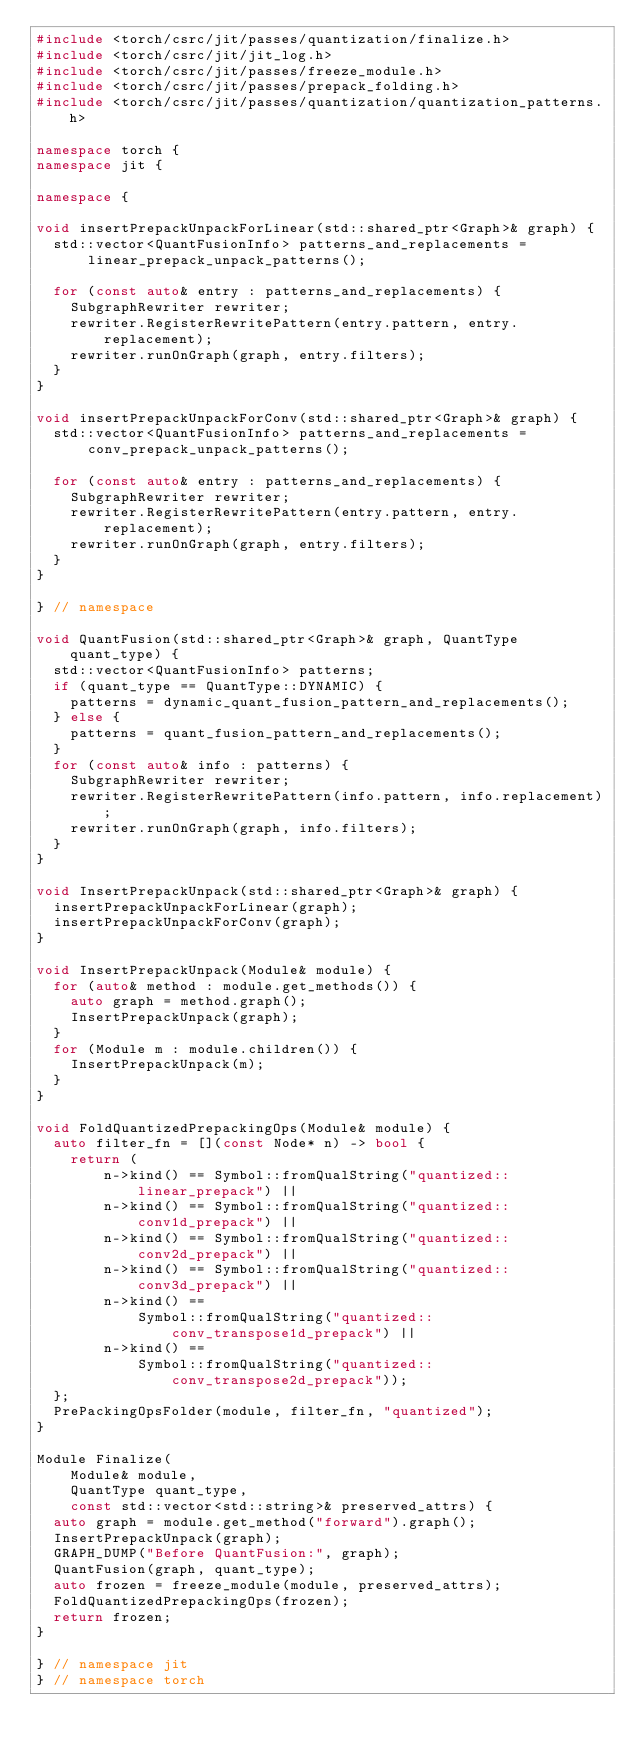Convert code to text. <code><loc_0><loc_0><loc_500><loc_500><_C++_>#include <torch/csrc/jit/passes/quantization/finalize.h>
#include <torch/csrc/jit/jit_log.h>
#include <torch/csrc/jit/passes/freeze_module.h>
#include <torch/csrc/jit/passes/prepack_folding.h>
#include <torch/csrc/jit/passes/quantization/quantization_patterns.h>

namespace torch {
namespace jit {

namespace {

void insertPrepackUnpackForLinear(std::shared_ptr<Graph>& graph) {
  std::vector<QuantFusionInfo> patterns_and_replacements =
      linear_prepack_unpack_patterns();

  for (const auto& entry : patterns_and_replacements) {
    SubgraphRewriter rewriter;
    rewriter.RegisterRewritePattern(entry.pattern, entry.replacement);
    rewriter.runOnGraph(graph, entry.filters);
  }
}

void insertPrepackUnpackForConv(std::shared_ptr<Graph>& graph) {
  std::vector<QuantFusionInfo> patterns_and_replacements =
      conv_prepack_unpack_patterns();

  for (const auto& entry : patterns_and_replacements) {
    SubgraphRewriter rewriter;
    rewriter.RegisterRewritePattern(entry.pattern, entry.replacement);
    rewriter.runOnGraph(graph, entry.filters);
  }
}

} // namespace

void QuantFusion(std::shared_ptr<Graph>& graph, QuantType quant_type) {
  std::vector<QuantFusionInfo> patterns;
  if (quant_type == QuantType::DYNAMIC) {
    patterns = dynamic_quant_fusion_pattern_and_replacements();
  } else {
    patterns = quant_fusion_pattern_and_replacements();
  }
  for (const auto& info : patterns) {
    SubgraphRewriter rewriter;
    rewriter.RegisterRewritePattern(info.pattern, info.replacement);
    rewriter.runOnGraph(graph, info.filters);
  }
}

void InsertPrepackUnpack(std::shared_ptr<Graph>& graph) {
  insertPrepackUnpackForLinear(graph);
  insertPrepackUnpackForConv(graph);
}

void InsertPrepackUnpack(Module& module) {
  for (auto& method : module.get_methods()) {
    auto graph = method.graph();
    InsertPrepackUnpack(graph);
  }
  for (Module m : module.children()) {
    InsertPrepackUnpack(m);
  }
}

void FoldQuantizedPrepackingOps(Module& module) {
  auto filter_fn = [](const Node* n) -> bool {
    return (
        n->kind() == Symbol::fromQualString("quantized::linear_prepack") ||
        n->kind() == Symbol::fromQualString("quantized::conv1d_prepack") ||
        n->kind() == Symbol::fromQualString("quantized::conv2d_prepack") ||
        n->kind() == Symbol::fromQualString("quantized::conv3d_prepack") ||
        n->kind() ==
            Symbol::fromQualString("quantized::conv_transpose1d_prepack") ||
        n->kind() ==
            Symbol::fromQualString("quantized::conv_transpose2d_prepack"));
  };
  PrePackingOpsFolder(module, filter_fn, "quantized");
}

Module Finalize(
    Module& module,
    QuantType quant_type,
    const std::vector<std::string>& preserved_attrs) {
  auto graph = module.get_method("forward").graph();
  InsertPrepackUnpack(graph);
  GRAPH_DUMP("Before QuantFusion:", graph);
  QuantFusion(graph, quant_type);
  auto frozen = freeze_module(module, preserved_attrs);
  FoldQuantizedPrepackingOps(frozen);
  return frozen;
}

} // namespace jit
} // namespace torch
</code> 